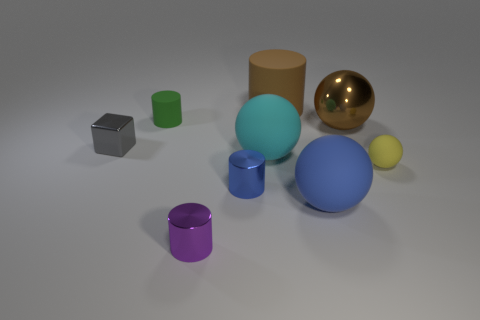There is a matte thing that is on the left side of the purple cylinder; what is its shape?
Your answer should be very brief. Cylinder. How many large objects are both in front of the tiny green matte cylinder and behind the blue rubber sphere?
Keep it short and to the point. 2. What number of other things are the same size as the cyan matte thing?
Offer a terse response. 3. Does the brown thing that is on the left side of the big brown sphere have the same shape as the small metal thing that is to the right of the purple object?
Keep it short and to the point. Yes. How many objects are small shiny cubes or rubber objects to the right of the big brown cylinder?
Ensure brevity in your answer.  3. There is a thing that is to the right of the green matte thing and behind the big brown metal object; what material is it?
Your response must be concise. Rubber. Is there anything else that is the same shape as the tiny purple object?
Your answer should be compact. Yes. There is a large ball that is made of the same material as the tiny purple thing; what is its color?
Offer a terse response. Brown. What number of objects are either large matte cylinders or gray cubes?
Give a very brief answer. 2. Does the blue shiny thing have the same size as the metallic thing behind the gray metal thing?
Give a very brief answer. No. 